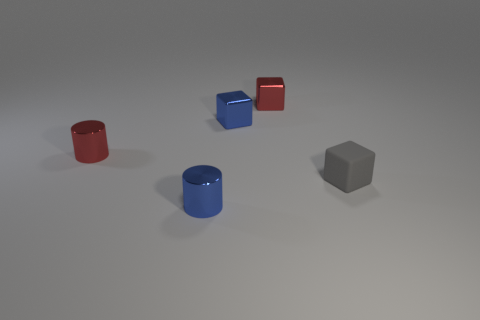There is a blue shiny block that is in front of the tiny red metal cube; what is its size?
Make the answer very short. Small. Is there any other thing that has the same material as the tiny gray cube?
Offer a very short reply. No. There is a metallic block on the left side of the red metal object that is to the right of the tiny red cylinder; what is its size?
Provide a succinct answer. Small. What color is the small object that is behind the tiny gray block and to the left of the small blue cube?
Ensure brevity in your answer.  Red. What number of other things are the same size as the matte cube?
Provide a succinct answer. 4. There is a rubber cube that is the same size as the blue shiny block; what color is it?
Make the answer very short. Gray. Is the tiny thing that is in front of the tiny gray rubber thing made of the same material as the small gray object?
Provide a succinct answer. No. What is the shape of the small red object behind the tiny blue metal thing that is behind the tiny metallic cylinder that is on the left side of the tiny blue cylinder?
Offer a terse response. Cube. Is the shape of the metallic thing behind the small blue block the same as the small red metallic object that is to the left of the tiny blue shiny cylinder?
Your answer should be very brief. No. Are there any red things that have the same material as the tiny gray thing?
Your answer should be compact. No. 